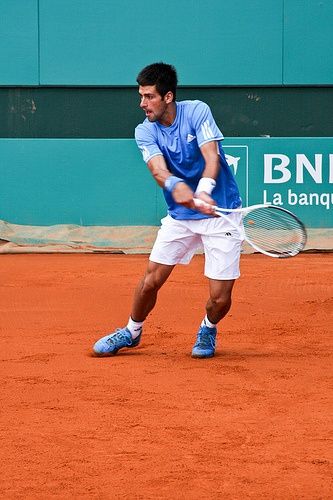Describe the objects in this image and their specific colors. I can see people in teal, lavender, maroon, black, and navy tones and tennis racket in teal, lightgray, darkgray, and tan tones in this image. 